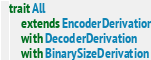<code> <loc_0><loc_0><loc_500><loc_500><_Scala_>trait All
    extends EncoderDerivation
    with DecoderDerivation
    with BinarySizeDerivation
</code> 